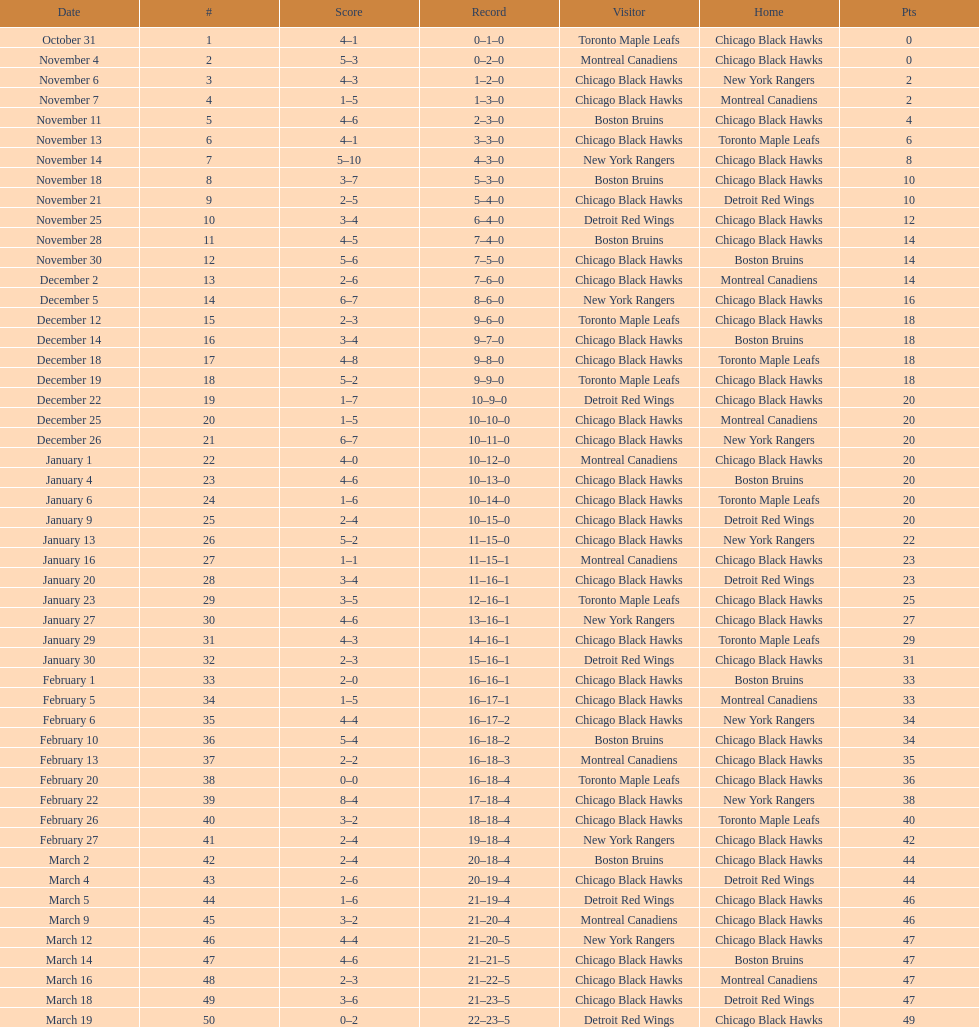What is the difference in pts between december 5th and november 11th? 3. 